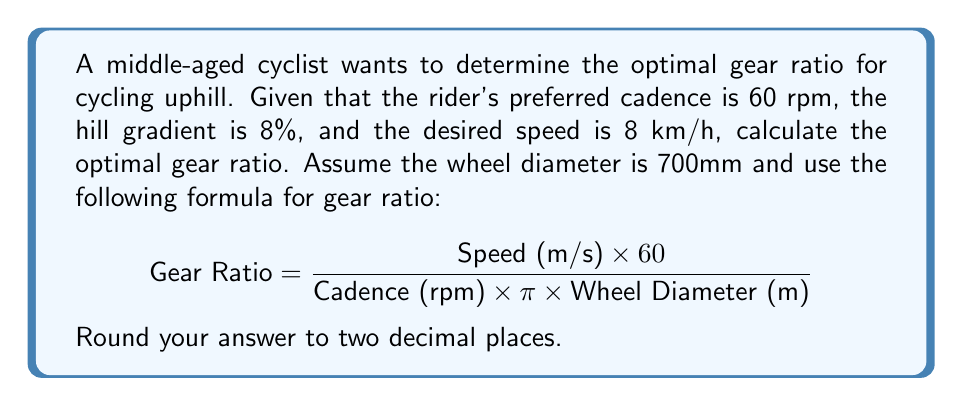Can you answer this question? To solve this problem, we'll follow these steps:

1. Convert the given speed from km/h to m/s:
   $$ 8 \text{ km/h} = 8 \times \frac{1000 \text{ m}}{3600 \text{ s}} = \frac{20}{9} \text{ m/s} $$

2. Convert the wheel diameter from mm to m:
   $$ 700 \text{ mm} = 0.7 \text{ m} $$

3. Substitute the values into the gear ratio formula:
   $$ \text{Gear Ratio} = \frac{\frac{20}{9} \text{ m/s} \times 60}{60 \text{ rpm} \times \pi \times 0.7 \text{ m}} $$

4. Simplify the equation:
   $$ \text{Gear Ratio} = \frac{400}{189\pi} $$

5. Calculate the result and round to two decimal places:
   $$ \text{Gear Ratio} \approx 0.67 $$

This gear ratio is relatively low, which is appropriate for climbing a steep hill at a moderate speed while maintaining a comfortable cadence for a middle-aged cyclist with a sedentary lifestyle.
Answer: The optimal gear ratio for cycling uphill under the given conditions is approximately 0.67. 